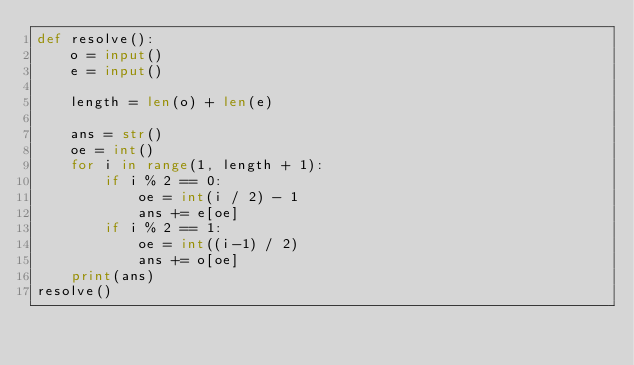Convert code to text. <code><loc_0><loc_0><loc_500><loc_500><_Python_>def resolve():
    o = input()
    e = input()

    length = len(o) + len(e)

    ans = str()
    oe = int()
    for i in range(1, length + 1):
        if i % 2 == 0:
            oe = int(i / 2) - 1
            ans += e[oe]
        if i % 2 == 1:
            oe = int((i-1) / 2)
            ans += o[oe]
    print(ans)
resolve()</code> 